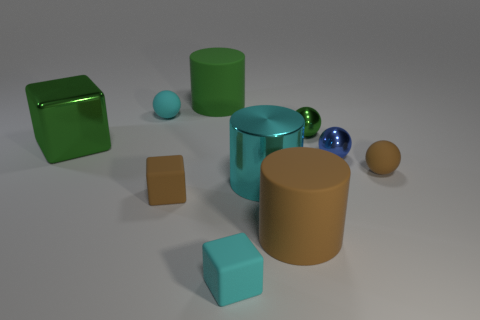What shapes are present in the image? In the image, you can see geometric shapes such as a cube, a cylinder, a sphere, and a couple of prisms. The arrangement of these shapes provides a simple yet interesting composition, which could be related to a study in form and structure or used for educational purposes. 